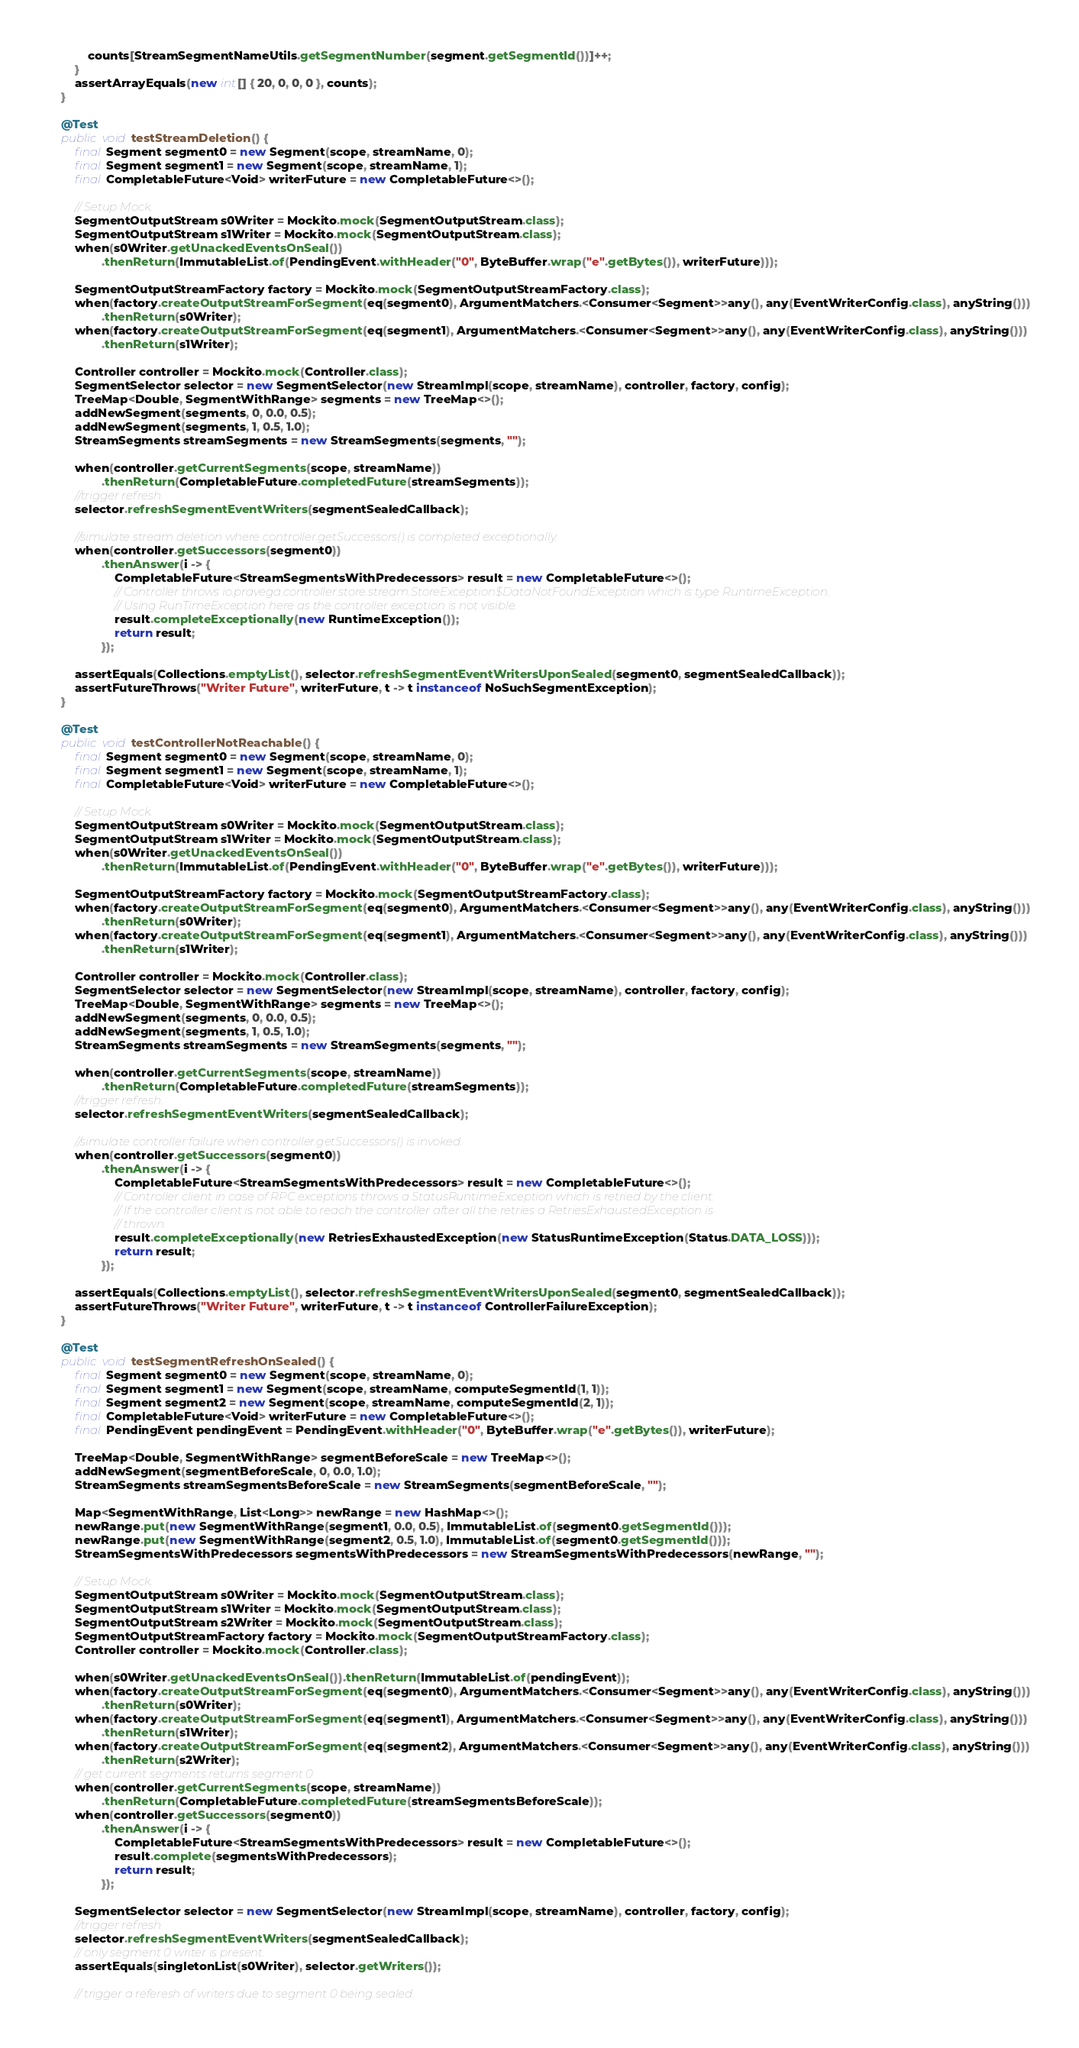<code> <loc_0><loc_0><loc_500><loc_500><_Java_>            counts[StreamSegmentNameUtils.getSegmentNumber(segment.getSegmentId())]++;
        }
        assertArrayEquals(new int[] { 20, 0, 0, 0 }, counts);
    }

    @Test
    public void testStreamDeletion() {
        final Segment segment0 = new Segment(scope, streamName, 0);
        final Segment segment1 = new Segment(scope, streamName, 1);
        final CompletableFuture<Void> writerFuture = new CompletableFuture<>();

        // Setup Mock.
        SegmentOutputStream s0Writer = Mockito.mock(SegmentOutputStream.class);
        SegmentOutputStream s1Writer = Mockito.mock(SegmentOutputStream.class);
        when(s0Writer.getUnackedEventsOnSeal())
                .thenReturn(ImmutableList.of(PendingEvent.withHeader("0", ByteBuffer.wrap("e".getBytes()), writerFuture)));

        SegmentOutputStreamFactory factory = Mockito.mock(SegmentOutputStreamFactory.class);
        when(factory.createOutputStreamForSegment(eq(segment0), ArgumentMatchers.<Consumer<Segment>>any(), any(EventWriterConfig.class), anyString()))
                .thenReturn(s0Writer);
        when(factory.createOutputStreamForSegment(eq(segment1), ArgumentMatchers.<Consumer<Segment>>any(), any(EventWriterConfig.class), anyString()))
                .thenReturn(s1Writer);

        Controller controller = Mockito.mock(Controller.class);
        SegmentSelector selector = new SegmentSelector(new StreamImpl(scope, streamName), controller, factory, config);
        TreeMap<Double, SegmentWithRange> segments = new TreeMap<>();
        addNewSegment(segments, 0, 0.0, 0.5);
        addNewSegment(segments, 1, 0.5, 1.0);
        StreamSegments streamSegments = new StreamSegments(segments, "");

        when(controller.getCurrentSegments(scope, streamName))
                .thenReturn(CompletableFuture.completedFuture(streamSegments));
        //trigger refresh.
        selector.refreshSegmentEventWriters(segmentSealedCallback);

        //simulate stream deletion where controller.getSuccessors() is completed exceptionally.
        when(controller.getSuccessors(segment0))
                .thenAnswer(i -> {
                    CompletableFuture<StreamSegmentsWithPredecessors> result = new CompletableFuture<>();
                    // Controller throws io.pravega.controller.store.stream.StoreException$DataNotFoundException which is type RuntimeException.
                    // Using RunTimeException here as the controller exception is not visible.
                    result.completeExceptionally(new RuntimeException());
                    return result;
                });

        assertEquals(Collections.emptyList(), selector.refreshSegmentEventWritersUponSealed(segment0, segmentSealedCallback));
        assertFutureThrows("Writer Future", writerFuture, t -> t instanceof NoSuchSegmentException);
    }

    @Test
    public void testControllerNotReachable() {
        final Segment segment0 = new Segment(scope, streamName, 0);
        final Segment segment1 = new Segment(scope, streamName, 1);
        final CompletableFuture<Void> writerFuture = new CompletableFuture<>();

        // Setup Mock.
        SegmentOutputStream s0Writer = Mockito.mock(SegmentOutputStream.class);
        SegmentOutputStream s1Writer = Mockito.mock(SegmentOutputStream.class);
        when(s0Writer.getUnackedEventsOnSeal())
                .thenReturn(ImmutableList.of(PendingEvent.withHeader("0", ByteBuffer.wrap("e".getBytes()), writerFuture)));

        SegmentOutputStreamFactory factory = Mockito.mock(SegmentOutputStreamFactory.class);
        when(factory.createOutputStreamForSegment(eq(segment0), ArgumentMatchers.<Consumer<Segment>>any(), any(EventWriterConfig.class), anyString()))
                .thenReturn(s0Writer);
        when(factory.createOutputStreamForSegment(eq(segment1), ArgumentMatchers.<Consumer<Segment>>any(), any(EventWriterConfig.class), anyString()))
                .thenReturn(s1Writer);

        Controller controller = Mockito.mock(Controller.class);
        SegmentSelector selector = new SegmentSelector(new StreamImpl(scope, streamName), controller, factory, config);
        TreeMap<Double, SegmentWithRange> segments = new TreeMap<>();
        addNewSegment(segments, 0, 0.0, 0.5);
        addNewSegment(segments, 1, 0.5, 1.0);
        StreamSegments streamSegments = new StreamSegments(segments, "");

        when(controller.getCurrentSegments(scope, streamName))
                .thenReturn(CompletableFuture.completedFuture(streamSegments));
        //trigger refresh.
        selector.refreshSegmentEventWriters(segmentSealedCallback);

        //simulate controller failure when controller.getSuccessors() is invoked.
        when(controller.getSuccessors(segment0))
                .thenAnswer(i -> {
                    CompletableFuture<StreamSegmentsWithPredecessors> result = new CompletableFuture<>();
                    // Controller client in case of RPC exceptions throws a StatusRuntimeException which is retried by the client.
                    // If the controller client is not able to reach the controller after all the retries a RetriesExhaustedException is
                    // thrown.
                    result.completeExceptionally(new RetriesExhaustedException(new StatusRuntimeException(Status.DATA_LOSS)));
                    return result;
                });

        assertEquals(Collections.emptyList(), selector.refreshSegmentEventWritersUponSealed(segment0, segmentSealedCallback));
        assertFutureThrows("Writer Future", writerFuture, t -> t instanceof ControllerFailureException);
    }

    @Test
    public void testSegmentRefreshOnSealed() {
        final Segment segment0 = new Segment(scope, streamName, 0);
        final Segment segment1 = new Segment(scope, streamName, computeSegmentId(1, 1));
        final Segment segment2 = new Segment(scope, streamName, computeSegmentId(2, 1));
        final CompletableFuture<Void> writerFuture = new CompletableFuture<>();
        final PendingEvent pendingEvent = PendingEvent.withHeader("0", ByteBuffer.wrap("e".getBytes()), writerFuture);

        TreeMap<Double, SegmentWithRange> segmentBeforeScale = new TreeMap<>();
        addNewSegment(segmentBeforeScale, 0, 0.0, 1.0);
        StreamSegments streamSegmentsBeforeScale = new StreamSegments(segmentBeforeScale, "");

        Map<SegmentWithRange, List<Long>> newRange = new HashMap<>();
        newRange.put(new SegmentWithRange(segment1, 0.0, 0.5), ImmutableList.of(segment0.getSegmentId()));
        newRange.put(new SegmentWithRange(segment2, 0.5, 1.0), ImmutableList.of(segment0.getSegmentId()));
        StreamSegmentsWithPredecessors segmentsWithPredecessors = new StreamSegmentsWithPredecessors(newRange, "");

        // Setup Mock.
        SegmentOutputStream s0Writer = Mockito.mock(SegmentOutputStream.class);
        SegmentOutputStream s1Writer = Mockito.mock(SegmentOutputStream.class);
        SegmentOutputStream s2Writer = Mockito.mock(SegmentOutputStream.class);
        SegmentOutputStreamFactory factory = Mockito.mock(SegmentOutputStreamFactory.class);
        Controller controller = Mockito.mock(Controller.class);

        when(s0Writer.getUnackedEventsOnSeal()).thenReturn(ImmutableList.of(pendingEvent));
        when(factory.createOutputStreamForSegment(eq(segment0), ArgumentMatchers.<Consumer<Segment>>any(), any(EventWriterConfig.class), anyString()))
                .thenReturn(s0Writer);
        when(factory.createOutputStreamForSegment(eq(segment1), ArgumentMatchers.<Consumer<Segment>>any(), any(EventWriterConfig.class), anyString()))
                .thenReturn(s1Writer);
        when(factory.createOutputStreamForSegment(eq(segment2), ArgumentMatchers.<Consumer<Segment>>any(), any(EventWriterConfig.class), anyString()))
                .thenReturn(s2Writer);
        // get current segments returns segment 0
        when(controller.getCurrentSegments(scope, streamName))
                .thenReturn(CompletableFuture.completedFuture(streamSegmentsBeforeScale));
        when(controller.getSuccessors(segment0))
                .thenAnswer(i -> {
                    CompletableFuture<StreamSegmentsWithPredecessors> result = new CompletableFuture<>();
                    result.complete(segmentsWithPredecessors);
                    return result;
                });

        SegmentSelector selector = new SegmentSelector(new StreamImpl(scope, streamName), controller, factory, config);
        //trigger refresh
        selector.refreshSegmentEventWriters(segmentSealedCallback);
        // only segment 0 writer is present.
        assertEquals(singletonList(s0Writer), selector.getWriters());

        // trigger a referesh of writers due to segment 0 being sealed.</code> 